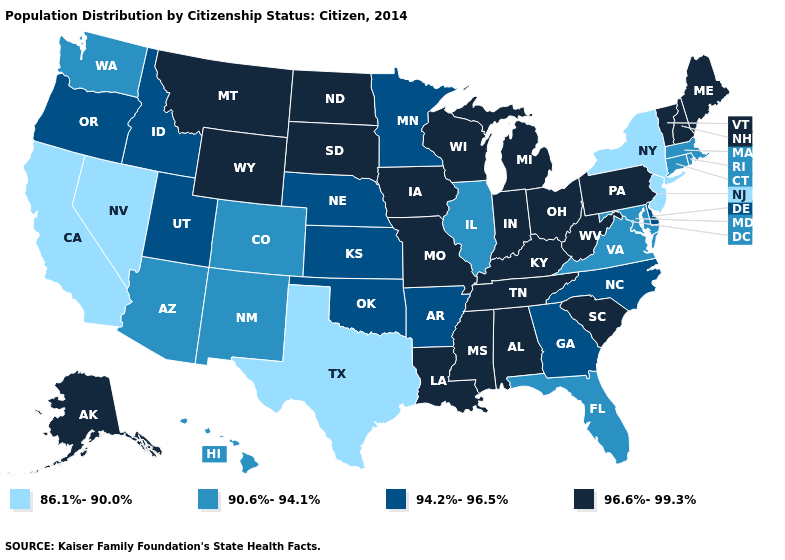Which states have the lowest value in the West?
Quick response, please. California, Nevada. Does Arizona have the same value as Missouri?
Concise answer only. No. Among the states that border Nevada , does California have the highest value?
Be succinct. No. Name the states that have a value in the range 90.6%-94.1%?
Write a very short answer. Arizona, Colorado, Connecticut, Florida, Hawaii, Illinois, Maryland, Massachusetts, New Mexico, Rhode Island, Virginia, Washington. Does Wisconsin have a lower value than Nebraska?
Answer briefly. No. Does Maine have the highest value in the USA?
Quick response, please. Yes. What is the highest value in the West ?
Answer briefly. 96.6%-99.3%. What is the highest value in states that border New Jersey?
Write a very short answer. 96.6%-99.3%. Name the states that have a value in the range 90.6%-94.1%?
Keep it brief. Arizona, Colorado, Connecticut, Florida, Hawaii, Illinois, Maryland, Massachusetts, New Mexico, Rhode Island, Virginia, Washington. Name the states that have a value in the range 96.6%-99.3%?
Quick response, please. Alabama, Alaska, Indiana, Iowa, Kentucky, Louisiana, Maine, Michigan, Mississippi, Missouri, Montana, New Hampshire, North Dakota, Ohio, Pennsylvania, South Carolina, South Dakota, Tennessee, Vermont, West Virginia, Wisconsin, Wyoming. Does Texas have the same value as Nevada?
Quick response, please. Yes. Among the states that border Vermont , does Massachusetts have the lowest value?
Be succinct. No. What is the lowest value in the West?
Concise answer only. 86.1%-90.0%. Does the map have missing data?
Keep it brief. No. What is the value of Delaware?
Be succinct. 94.2%-96.5%. 